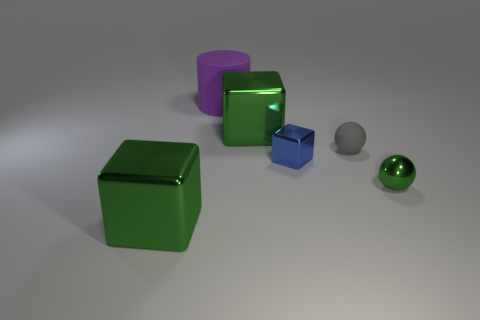Subtract all big green metal cubes. How many cubes are left? 1 Subtract all green balls. How many balls are left? 1 Add 1 blue shiny cubes. How many objects exist? 7 Subtract 2 cubes. How many cubes are left? 1 Subtract all cyan cubes. Subtract all purple balls. How many cubes are left? 3 Subtract all cyan spheres. How many green blocks are left? 2 Subtract all tiny blue rubber objects. Subtract all blue shiny things. How many objects are left? 5 Add 5 green balls. How many green balls are left? 6 Add 3 small cyan rubber balls. How many small cyan rubber balls exist? 3 Subtract 1 green spheres. How many objects are left? 5 